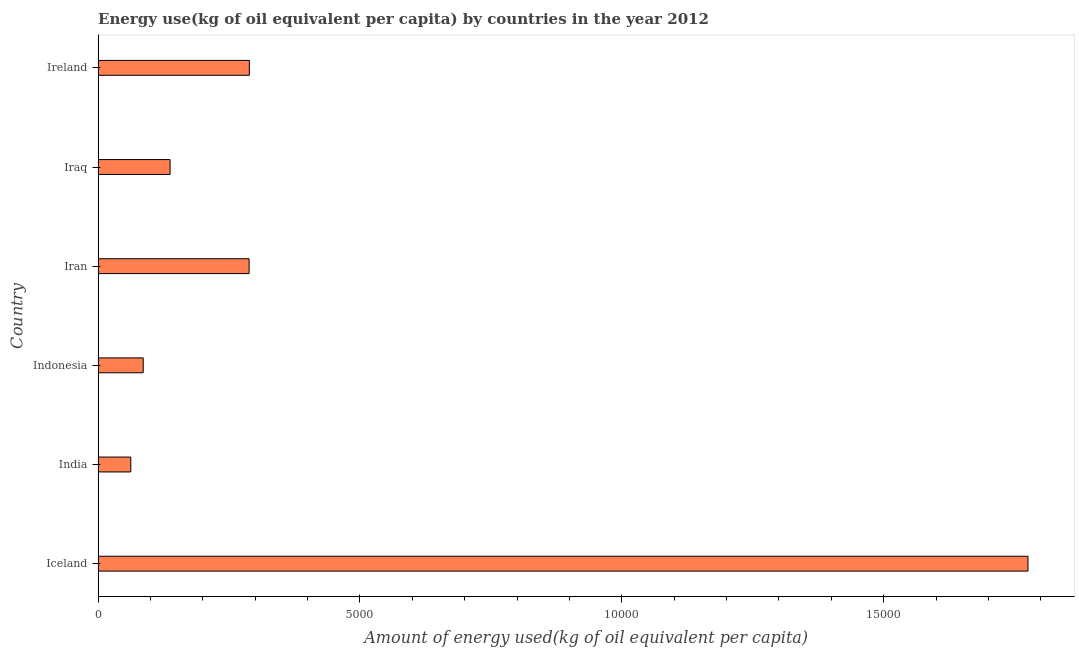Does the graph contain any zero values?
Your answer should be very brief. No. What is the title of the graph?
Keep it short and to the point. Energy use(kg of oil equivalent per capita) by countries in the year 2012. What is the label or title of the X-axis?
Ensure brevity in your answer.  Amount of energy used(kg of oil equivalent per capita). What is the label or title of the Y-axis?
Your response must be concise. Country. What is the amount of energy used in Iceland?
Ensure brevity in your answer.  1.78e+04. Across all countries, what is the maximum amount of energy used?
Make the answer very short. 1.78e+04. Across all countries, what is the minimum amount of energy used?
Provide a succinct answer. 623.72. What is the sum of the amount of energy used?
Make the answer very short. 2.64e+04. What is the difference between the amount of energy used in Iran and Iraq?
Your answer should be compact. 1509.29. What is the average amount of energy used per country?
Offer a terse response. 4397.59. What is the median amount of energy used?
Your answer should be compact. 2128.75. What is the ratio of the amount of energy used in Indonesia to that in Iraq?
Ensure brevity in your answer.  0.63. Is the amount of energy used in Iceland less than that in Ireland?
Provide a succinct answer. No. Is the difference between the amount of energy used in Iceland and Iraq greater than the difference between any two countries?
Your answer should be compact. No. What is the difference between the highest and the second highest amount of energy used?
Your response must be concise. 1.49e+04. What is the difference between the highest and the lowest amount of energy used?
Keep it short and to the point. 1.71e+04. In how many countries, is the amount of energy used greater than the average amount of energy used taken over all countries?
Give a very brief answer. 1. How many bars are there?
Provide a short and direct response. 6. Are all the bars in the graph horizontal?
Your response must be concise. Yes. What is the difference between two consecutive major ticks on the X-axis?
Provide a succinct answer. 5000. What is the Amount of energy used(kg of oil equivalent per capita) in Iceland?
Offer a very short reply. 1.78e+04. What is the Amount of energy used(kg of oil equivalent per capita) of India?
Give a very brief answer. 623.72. What is the Amount of energy used(kg of oil equivalent per capita) of Indonesia?
Give a very brief answer. 861.11. What is the Amount of energy used(kg of oil equivalent per capita) in Iran?
Offer a very short reply. 2883.39. What is the Amount of energy used(kg of oil equivalent per capita) in Iraq?
Give a very brief answer. 1374.11. What is the Amount of energy used(kg of oil equivalent per capita) of Ireland?
Make the answer very short. 2887.62. What is the difference between the Amount of energy used(kg of oil equivalent per capita) in Iceland and India?
Provide a succinct answer. 1.71e+04. What is the difference between the Amount of energy used(kg of oil equivalent per capita) in Iceland and Indonesia?
Offer a very short reply. 1.69e+04. What is the difference between the Amount of energy used(kg of oil equivalent per capita) in Iceland and Iran?
Give a very brief answer. 1.49e+04. What is the difference between the Amount of energy used(kg of oil equivalent per capita) in Iceland and Iraq?
Your answer should be very brief. 1.64e+04. What is the difference between the Amount of energy used(kg of oil equivalent per capita) in Iceland and Ireland?
Your answer should be very brief. 1.49e+04. What is the difference between the Amount of energy used(kg of oil equivalent per capita) in India and Indonesia?
Make the answer very short. -237.39. What is the difference between the Amount of energy used(kg of oil equivalent per capita) in India and Iran?
Provide a succinct answer. -2259.67. What is the difference between the Amount of energy used(kg of oil equivalent per capita) in India and Iraq?
Provide a short and direct response. -750.39. What is the difference between the Amount of energy used(kg of oil equivalent per capita) in India and Ireland?
Your response must be concise. -2263.9. What is the difference between the Amount of energy used(kg of oil equivalent per capita) in Indonesia and Iran?
Make the answer very short. -2022.29. What is the difference between the Amount of energy used(kg of oil equivalent per capita) in Indonesia and Iraq?
Your answer should be very brief. -513. What is the difference between the Amount of energy used(kg of oil equivalent per capita) in Indonesia and Ireland?
Provide a succinct answer. -2026.51. What is the difference between the Amount of energy used(kg of oil equivalent per capita) in Iran and Iraq?
Your answer should be compact. 1509.29. What is the difference between the Amount of energy used(kg of oil equivalent per capita) in Iran and Ireland?
Provide a short and direct response. -4.23. What is the difference between the Amount of energy used(kg of oil equivalent per capita) in Iraq and Ireland?
Make the answer very short. -1513.51. What is the ratio of the Amount of energy used(kg of oil equivalent per capita) in Iceland to that in India?
Offer a terse response. 28.47. What is the ratio of the Amount of energy used(kg of oil equivalent per capita) in Iceland to that in Indonesia?
Keep it short and to the point. 20.62. What is the ratio of the Amount of energy used(kg of oil equivalent per capita) in Iceland to that in Iran?
Make the answer very short. 6.16. What is the ratio of the Amount of energy used(kg of oil equivalent per capita) in Iceland to that in Iraq?
Provide a short and direct response. 12.92. What is the ratio of the Amount of energy used(kg of oil equivalent per capita) in Iceland to that in Ireland?
Provide a short and direct response. 6.15. What is the ratio of the Amount of energy used(kg of oil equivalent per capita) in India to that in Indonesia?
Offer a very short reply. 0.72. What is the ratio of the Amount of energy used(kg of oil equivalent per capita) in India to that in Iran?
Offer a very short reply. 0.22. What is the ratio of the Amount of energy used(kg of oil equivalent per capita) in India to that in Iraq?
Offer a terse response. 0.45. What is the ratio of the Amount of energy used(kg of oil equivalent per capita) in India to that in Ireland?
Keep it short and to the point. 0.22. What is the ratio of the Amount of energy used(kg of oil equivalent per capita) in Indonesia to that in Iran?
Provide a short and direct response. 0.3. What is the ratio of the Amount of energy used(kg of oil equivalent per capita) in Indonesia to that in Iraq?
Make the answer very short. 0.63. What is the ratio of the Amount of energy used(kg of oil equivalent per capita) in Indonesia to that in Ireland?
Your answer should be very brief. 0.3. What is the ratio of the Amount of energy used(kg of oil equivalent per capita) in Iran to that in Iraq?
Your answer should be compact. 2.1. What is the ratio of the Amount of energy used(kg of oil equivalent per capita) in Iraq to that in Ireland?
Provide a short and direct response. 0.48. 